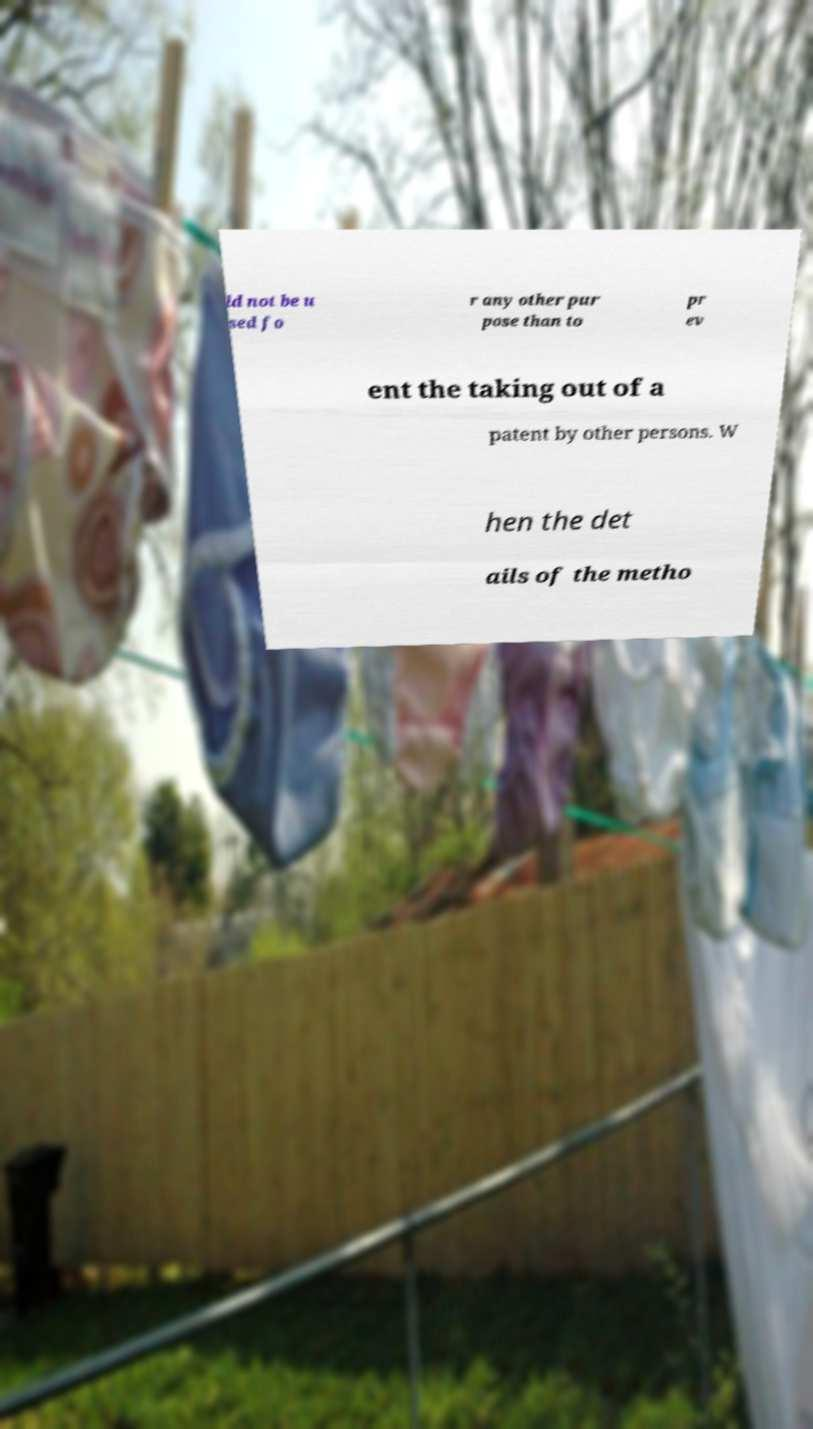Could you extract and type out the text from this image? ld not be u sed fo r any other pur pose than to pr ev ent the taking out of a patent by other persons. W hen the det ails of the metho 